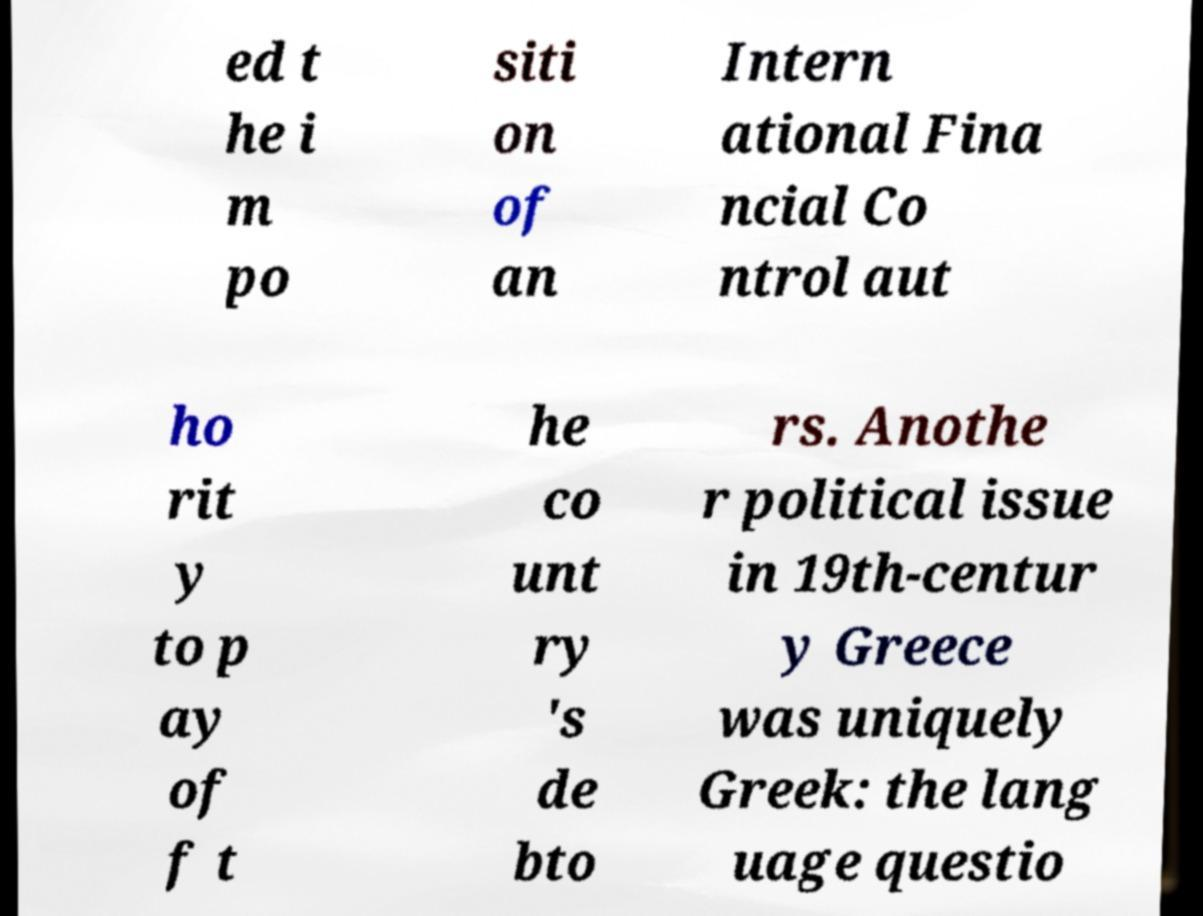I need the written content from this picture converted into text. Can you do that? ed t he i m po siti on of an Intern ational Fina ncial Co ntrol aut ho rit y to p ay of f t he co unt ry 's de bto rs. Anothe r political issue in 19th-centur y Greece was uniquely Greek: the lang uage questio 